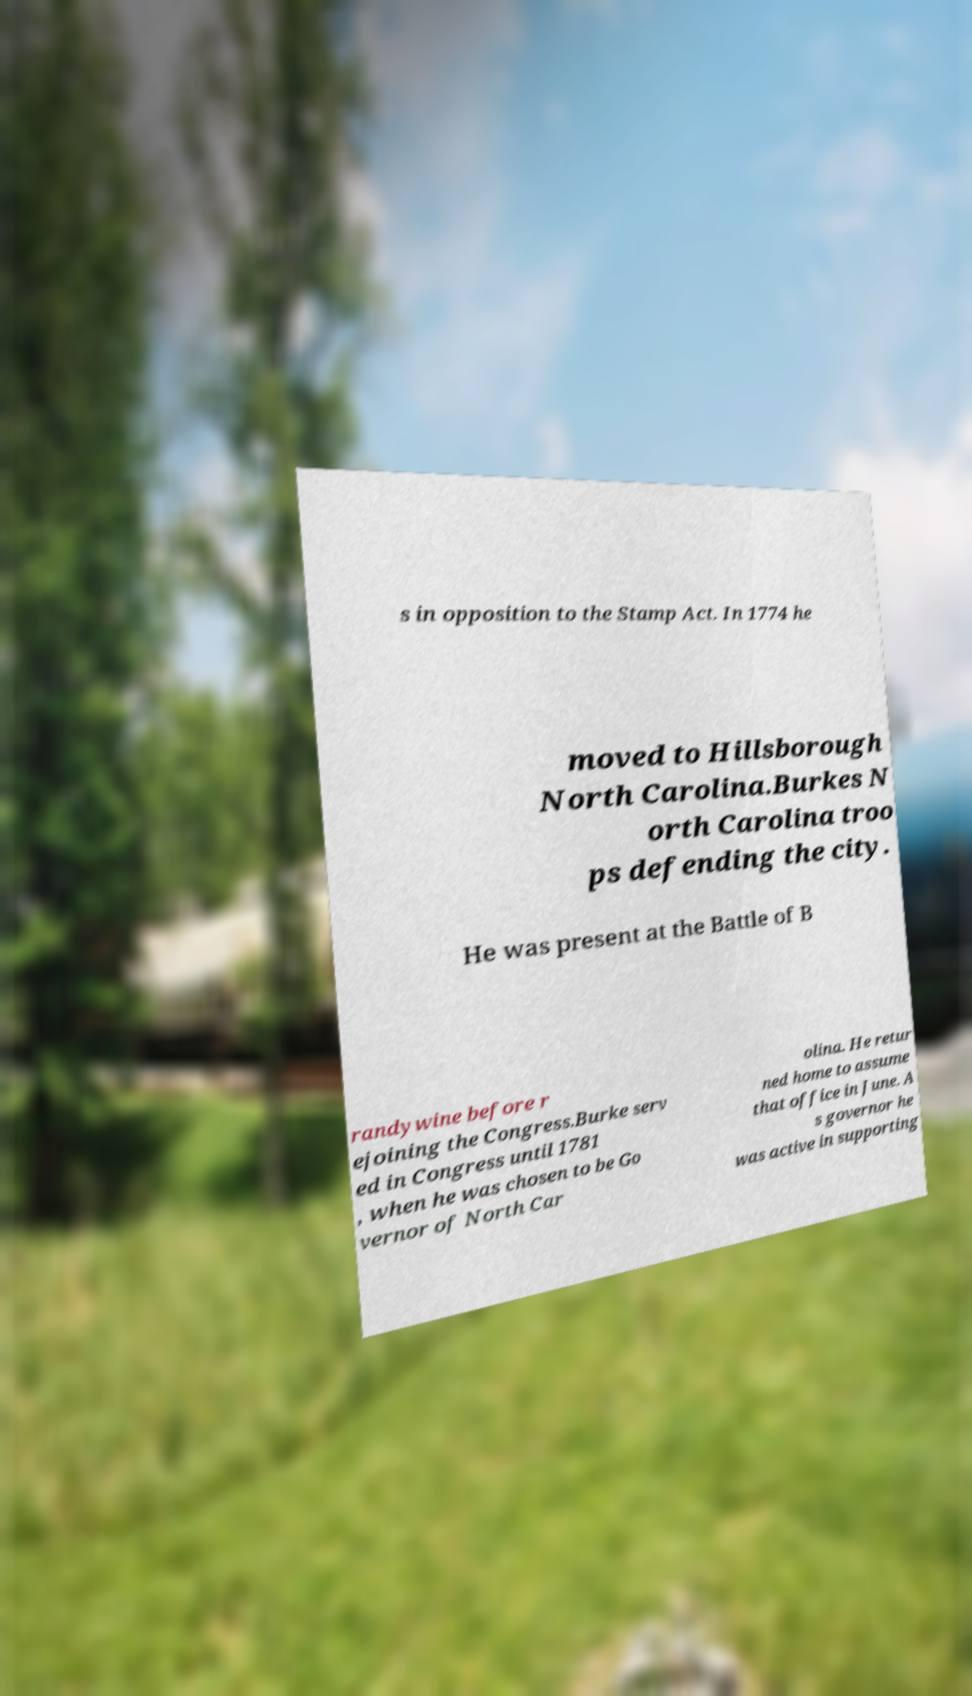Please identify and transcribe the text found in this image. s in opposition to the Stamp Act. In 1774 he moved to Hillsborough North Carolina.Burkes N orth Carolina troo ps defending the city. He was present at the Battle of B randywine before r ejoining the Congress.Burke serv ed in Congress until 1781 , when he was chosen to be Go vernor of North Car olina. He retur ned home to assume that office in June. A s governor he was active in supporting 